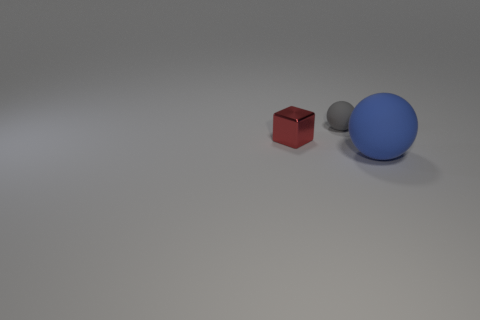There is a gray object; how many balls are on the right side of it?
Keep it short and to the point. 1. What is the color of the object that is made of the same material as the large sphere?
Provide a short and direct response. Gray. There is a gray matte thing; is its size the same as the matte ball that is in front of the small gray object?
Offer a terse response. No. There is a sphere that is on the right side of the sphere behind the thing that is to the left of the small gray rubber thing; what size is it?
Provide a succinct answer. Large. How many rubber things are gray spheres or green blocks?
Provide a succinct answer. 1. The thing behind the small red thing is what color?
Your answer should be very brief. Gray. What is the shape of the other matte thing that is the same size as the red thing?
Your answer should be very brief. Sphere. What number of objects are either red shiny objects behind the large blue rubber ball or tiny things that are in front of the tiny gray matte thing?
Offer a terse response. 1. There is a red object that is the same size as the gray ball; what is it made of?
Your response must be concise. Metal. What number of other objects are there of the same material as the tiny block?
Make the answer very short. 0. 